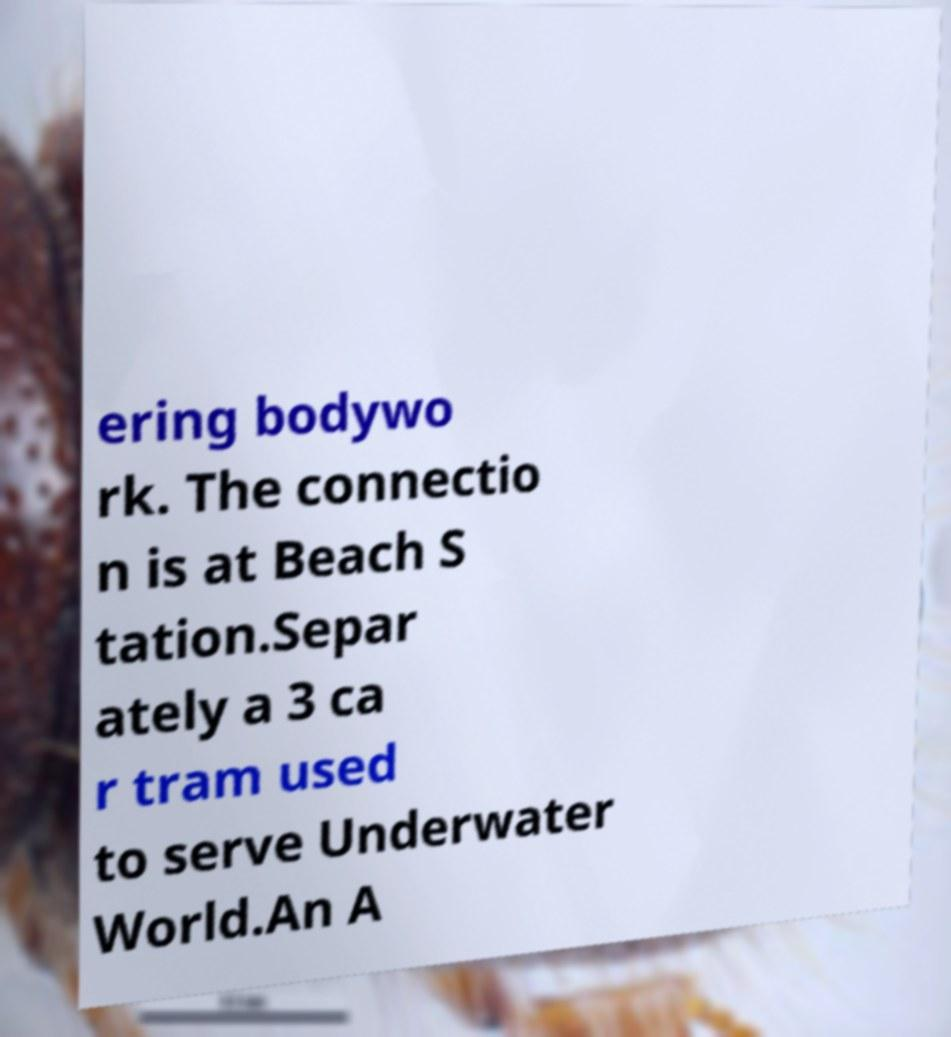What messages or text are displayed in this image? I need them in a readable, typed format. ering bodywo rk. The connectio n is at Beach S tation.Separ ately a 3 ca r tram used to serve Underwater World.An A 